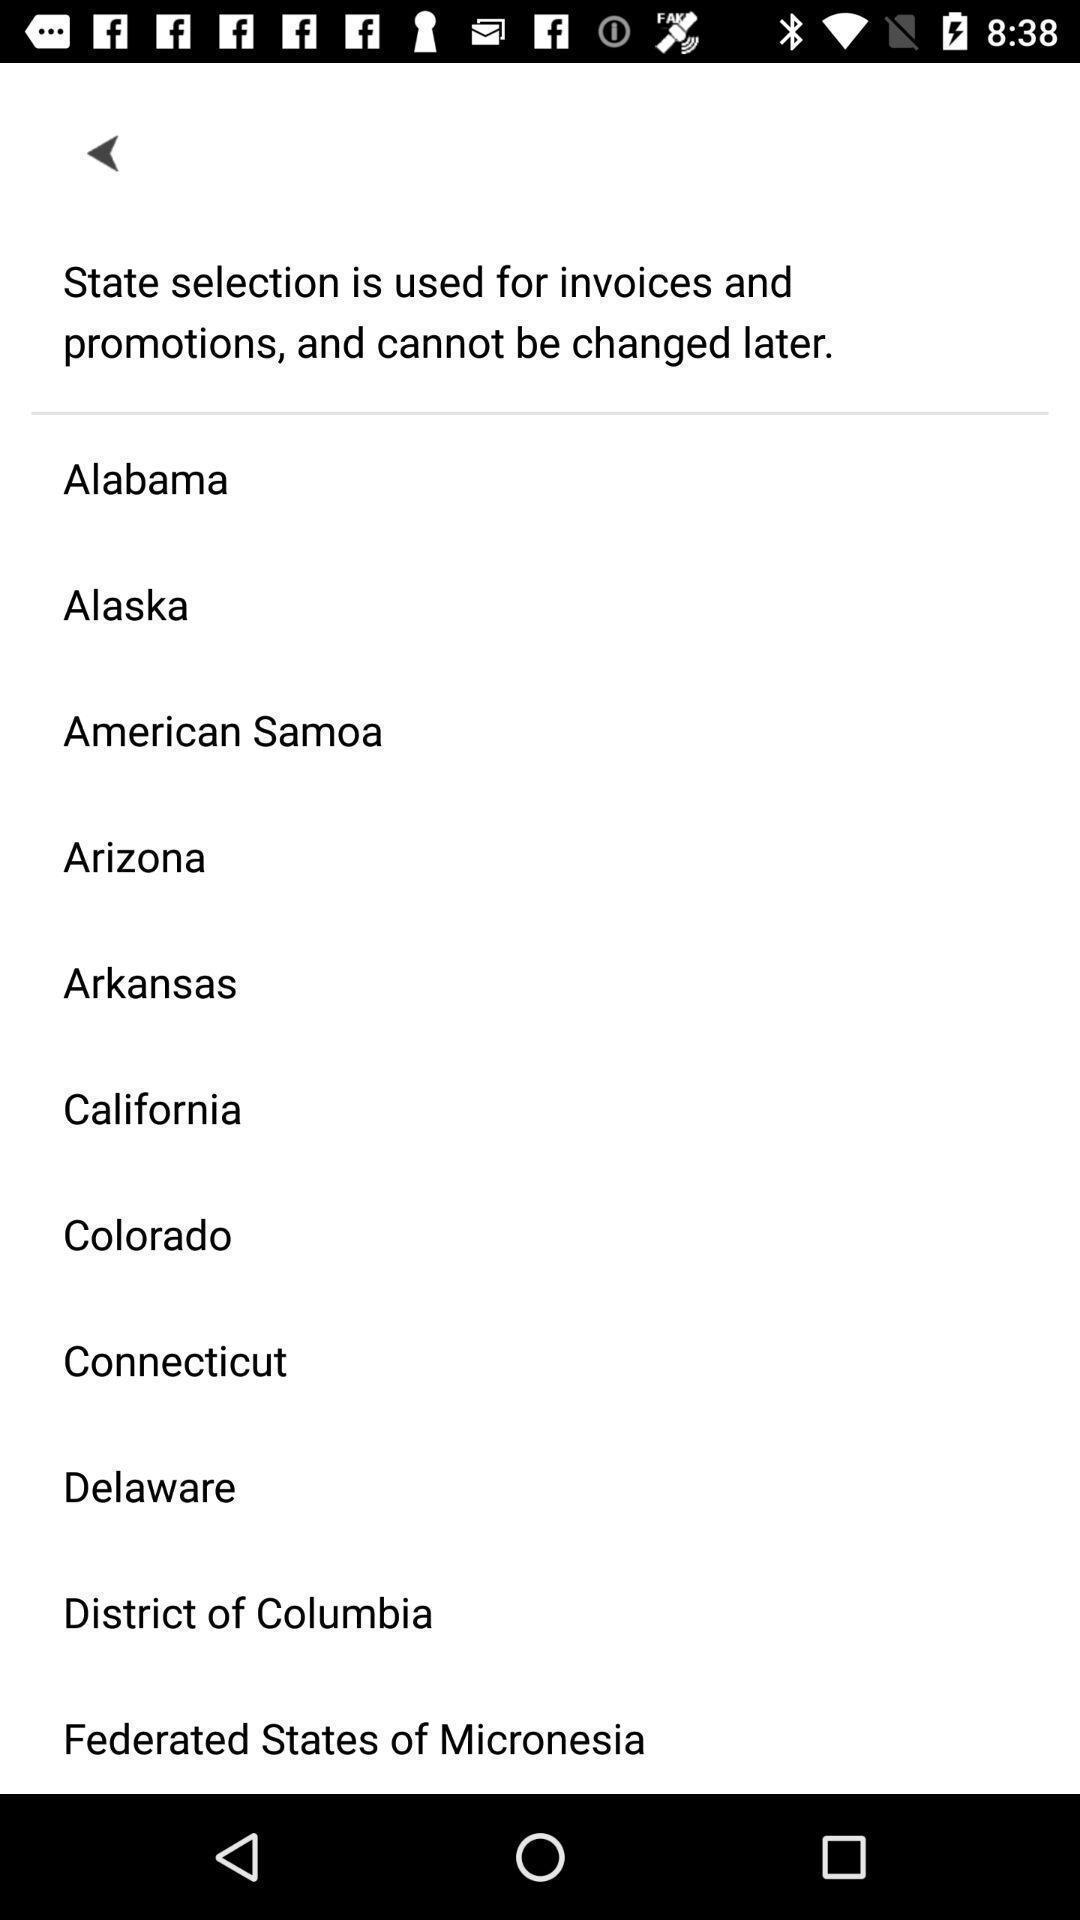Summarize the information in this screenshot. Page showing location selection options in a route navigation app. 